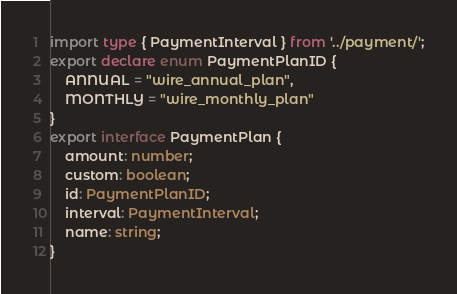<code> <loc_0><loc_0><loc_500><loc_500><_TypeScript_>import type { PaymentInterval } from '../payment/';
export declare enum PaymentPlanID {
    ANNUAL = "wire_annual_plan",
    MONTHLY = "wire_monthly_plan"
}
export interface PaymentPlan {
    amount: number;
    custom: boolean;
    id: PaymentPlanID;
    interval: PaymentInterval;
    name: string;
}
</code> 